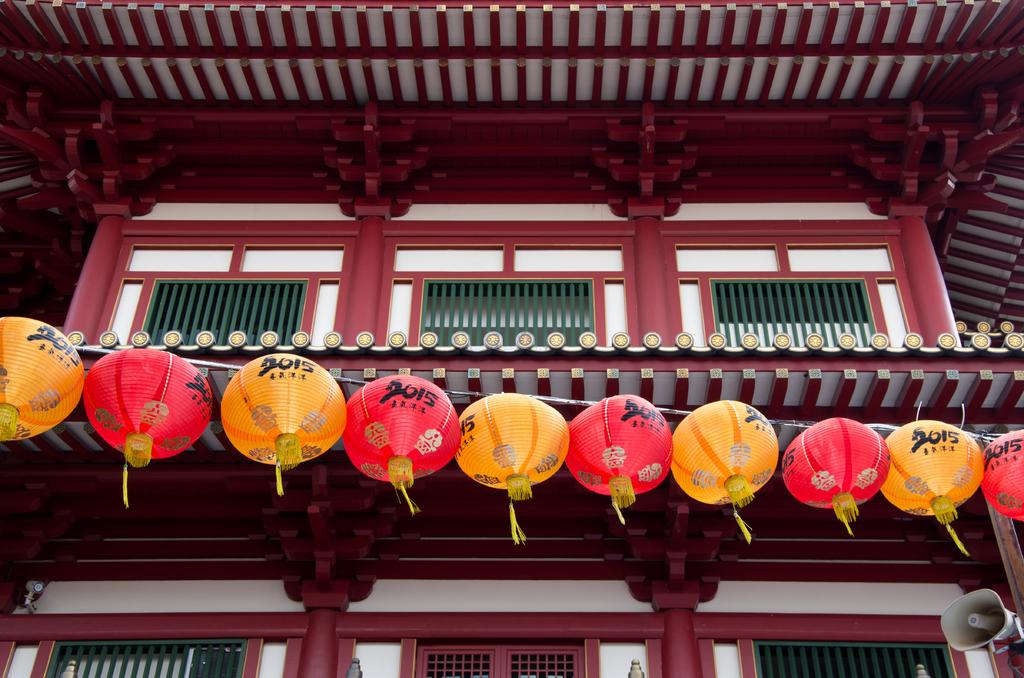Are those pumpkin fall balloons?
Offer a very short reply. Answering does not require reading text in the image. 